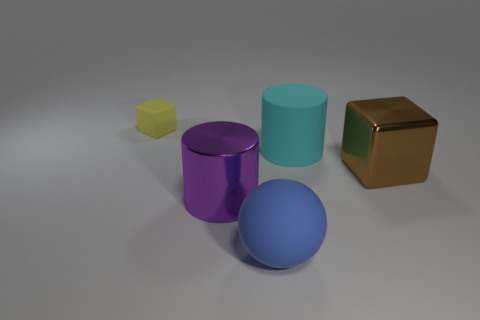Add 3 big cyan objects. How many objects exist? 8 Subtract all cubes. How many objects are left? 3 Subtract all purple cylinders. Subtract all small yellow things. How many objects are left? 3 Add 2 yellow blocks. How many yellow blocks are left? 3 Add 5 big brown metallic cubes. How many big brown metallic cubes exist? 6 Subtract 1 cyan cylinders. How many objects are left? 4 